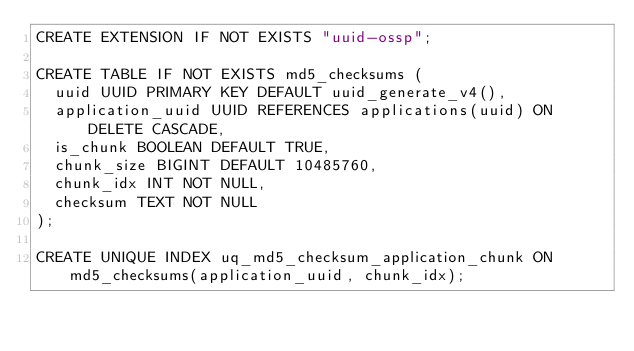<code> <loc_0><loc_0><loc_500><loc_500><_SQL_>CREATE EXTENSION IF NOT EXISTS "uuid-ossp";

CREATE TABLE IF NOT EXISTS md5_checksums (
  uuid UUID PRIMARY KEY DEFAULT uuid_generate_v4(),
  application_uuid UUID REFERENCES applications(uuid) ON DELETE CASCADE,
  is_chunk BOOLEAN DEFAULT TRUE,
  chunk_size BIGINT DEFAULT 10485760,
  chunk_idx INT NOT NULL,
  checksum TEXT NOT NULL
);

CREATE UNIQUE INDEX uq_md5_checksum_application_chunk ON md5_checksums(application_uuid, chunk_idx);
</code> 